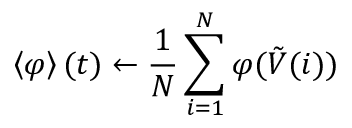Convert formula to latex. <formula><loc_0><loc_0><loc_500><loc_500>\left \langle \varphi \right \rangle ( t ) \gets \frac { 1 } { N } \sum _ { i = 1 } ^ { N } \varphi ( \tilde { V } ( i ) )</formula> 